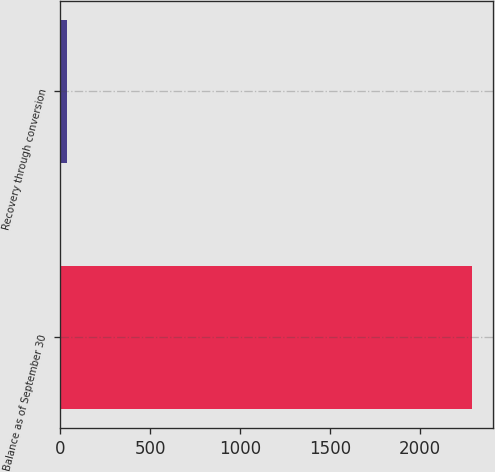Convert chart. <chart><loc_0><loc_0><loc_500><loc_500><bar_chart><fcel>Balance as of September 30<fcel>Recovery through conversion<nl><fcel>2291<fcel>35<nl></chart> 